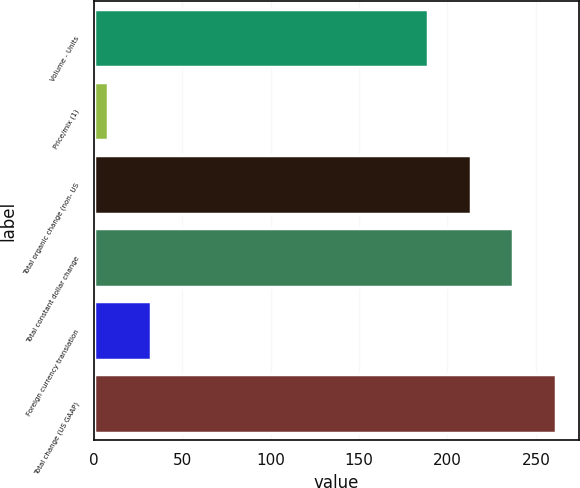Convert chart to OTSL. <chart><loc_0><loc_0><loc_500><loc_500><bar_chart><fcel>Volume - Units<fcel>Price/mix (1)<fcel>Total organic change (non- US<fcel>Total constant dollar change<fcel>Foreign currency translation<fcel>Total change (US GAAP)<nl><fcel>188.8<fcel>8<fcel>213.03<fcel>237.26<fcel>32.23<fcel>261.49<nl></chart> 